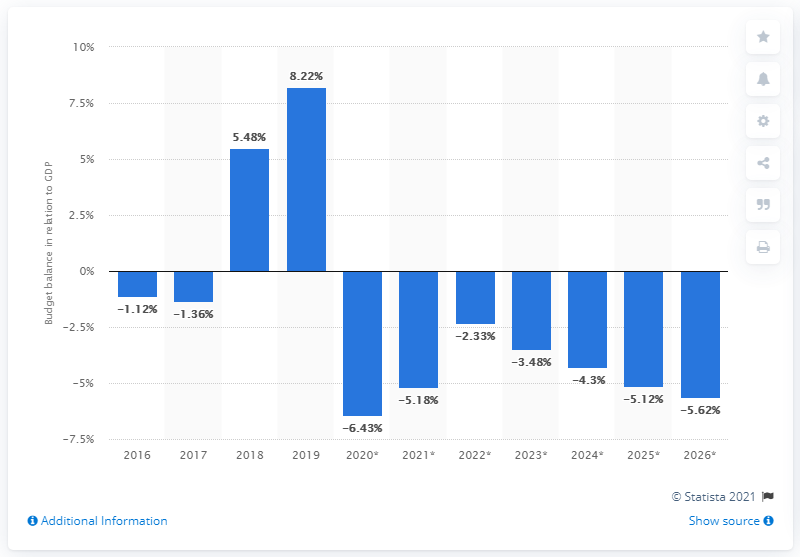List a handful of essential elements in this visual. In 2019, Azerbaijan's budget surplus accounted for 8.22% of its Gross Domestic Product (GDP). 